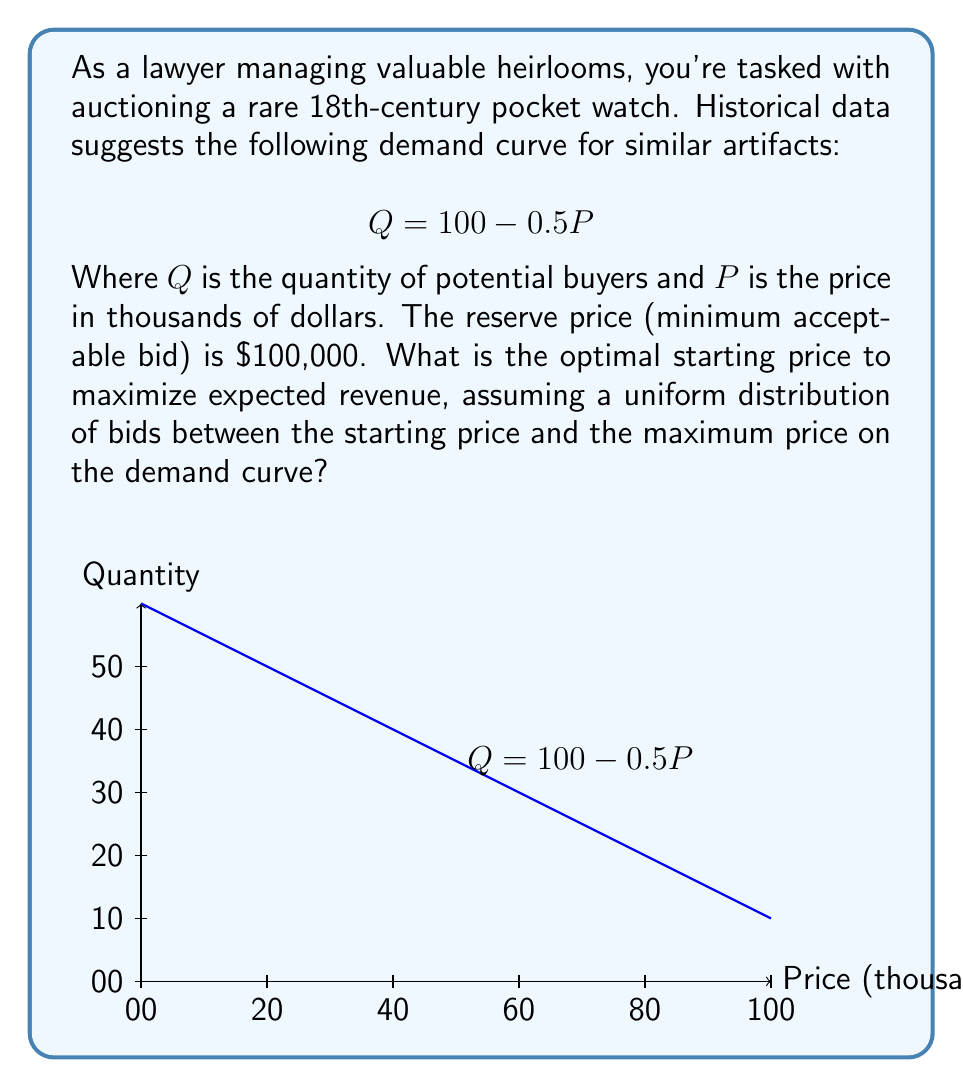Teach me how to tackle this problem. Let's approach this step-by-step:

1) First, we need to find the maximum price on the demand curve. When Q = 0:
   $$ 0 = 100 - 0.5P $$
   $$ 0.5P = 100 $$
   $$ P = 200 $$
   So, the maximum price is $200,000.

2) Let $x$ be the starting price in thousands of dollars. The expected revenue $R(x)$ is:
   $$ R(x) = x \cdot P({\text{bid} \geq x}) \cdot Q(x) $$

3) $P({\text{bid} \geq x})$ is the probability that a bid will be at least $x$, given a uniform distribution between $x$ and 200:
   $$ P({\text{bid} \geq x}) = \frac{200-x}{200-x} = 1 $$

4) $Q(x)$ is the number of potential buyers at price $x$:
   $$ Q(x) = 100 - 0.5x $$

5) Therefore, the revenue function is:
   $$ R(x) = x \cdot (100 - 0.5x) = 100x - 0.5x^2 $$

6) To maximize revenue, we differentiate $R(x)$ and set it to zero:
   $$ \frac{dR}{dx} = 100 - x = 0 $$
   $$ x = 100 $$

7) The second derivative is negative $(-1)$, confirming this is a maximum.

8) However, we must check if this satisfies the reserve price constraint. Since $100,000 = $100 (in thousands), our optimal starting price is indeed $100,000.
Answer: $100,000 